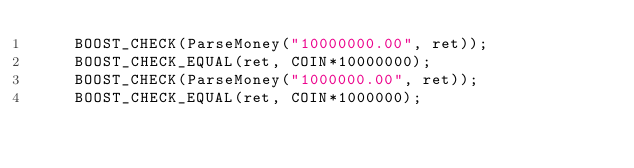<code> <loc_0><loc_0><loc_500><loc_500><_C++_>    BOOST_CHECK(ParseMoney("10000000.00", ret));
    BOOST_CHECK_EQUAL(ret, COIN*10000000);
    BOOST_CHECK(ParseMoney("1000000.00", ret));
    BOOST_CHECK_EQUAL(ret, COIN*1000000);</code> 